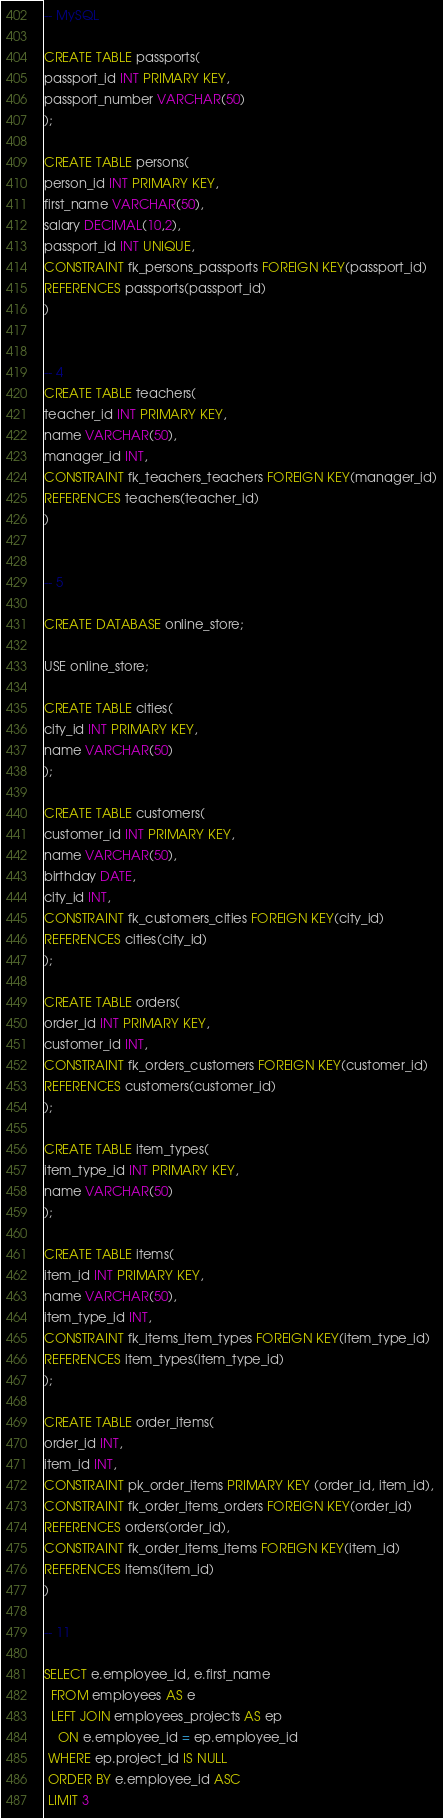Convert code to text. <code><loc_0><loc_0><loc_500><loc_500><_SQL_>-- MySQL 

CREATE TABLE passports(
passport_id INT PRIMARY KEY,
passport_number VARCHAR(50)
);

CREATE TABLE persons(
person_id INT PRIMARY KEY,
first_name VARCHAR(50),
salary DECIMAL(10,2),
passport_id INT UNIQUE,
CONSTRAINT fk_persons_passports FOREIGN KEY(passport_id)
REFERENCES passports(passport_id)
)


-- 4
CREATE TABLE teachers(
teacher_id INT PRIMARY KEY,
name VARCHAR(50),
manager_id INT,
CONSTRAINT fk_teachers_teachers FOREIGN KEY(manager_id)
REFERENCES teachers(teacher_id)
)


-- 5

CREATE DATABASE online_store;

USE online_store;

CREATE TABLE cities(
city_id INT PRIMARY KEY,
name VARCHAR(50)
);

CREATE TABLE customers(
customer_id INT PRIMARY KEY,
name VARCHAR(50),
birthday DATE,
city_id INT,
CONSTRAINT fk_customers_cities FOREIGN KEY(city_id)
REFERENCES cities(city_id)
);

CREATE TABLE orders(
order_id INT PRIMARY KEY,
customer_id INT,
CONSTRAINT fk_orders_customers FOREIGN KEY(customer_id)
REFERENCES customers(customer_id)
);

CREATE TABLE item_types(
item_type_id INT PRIMARY KEY,
name VARCHAR(50)
);

CREATE TABLE items(
item_id INT PRIMARY KEY,
name VARCHAR(50),
item_type_id INT,
CONSTRAINT fk_items_item_types FOREIGN KEY(item_type_id)
REFERENCES item_types(item_type_id)
);

CREATE TABLE order_items(
order_id INT,
item_id INT,
CONSTRAINT pk_order_items PRIMARY KEY (order_id, item_id),
CONSTRAINT fk_order_items_orders FOREIGN KEY(order_id)
REFERENCES orders(order_id),
CONSTRAINT fk_order_items_items FOREIGN KEY(item_id)
REFERENCES items(item_id)
)

-- 11

SELECT e.employee_id, e.first_name 
  FROM employees AS e
  LEFT JOIN employees_projects AS ep
    ON e.employee_id = ep.employee_id
 WHERE ep.project_id IS NULL
 ORDER BY e.employee_id ASC
 LIMIT 3
</code> 